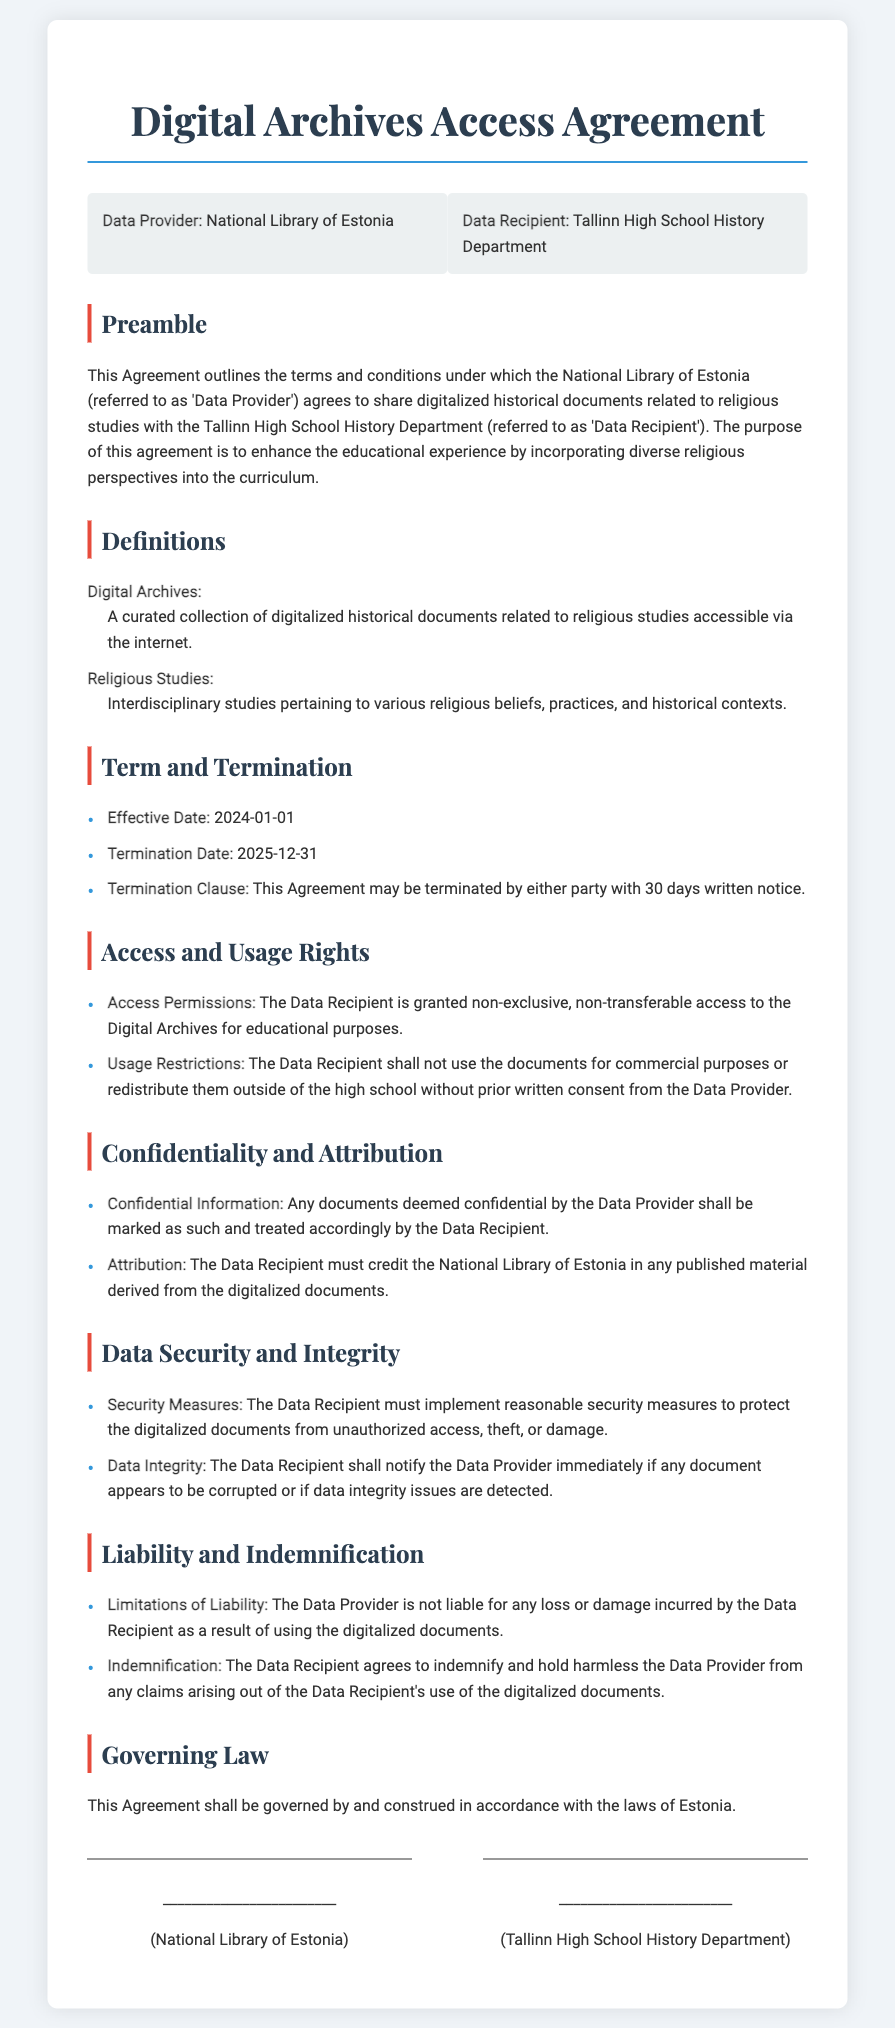What is the name of the Data Provider? The Data Provider is specifically named in the document as the organization sharing the digitalized documents.
Answer: National Library of Estonia What is the Effective Date of the Agreement? The Effective Date is the date when the Agreement comes into force, which is explicitly stated in the document.
Answer: 2024-01-01 What are the access permissions granted to the Data Recipient? The document specifies the type of access granted to the Data Recipient regarding the digital archives.
Answer: Non-exclusive, non-transferable access for educational purposes How long is the duration of the Agreement? The duration is defined by the Effective Date and Termination Date provided in the document.
Answer: Two years What must the Data Recipient do if documents appear corrupted? The document outlines the responsibility of the Data Recipient in case of data integrity issues.
Answer: Notify the Data Provider immediately What is the governing law of the Agreement? This refers to the legal framework under which the Agreement is made, as stated in the document.
Answer: Laws of Estonia What is the termination notice period? The document specifies how much notice must be given for termination of the Agreement.
Answer: 30 days written notice What type of information is considered confidential? The document implies that any documents marked by the Data Provider fall under this category.
Answer: Documents deemed confidential by the Data Provider 